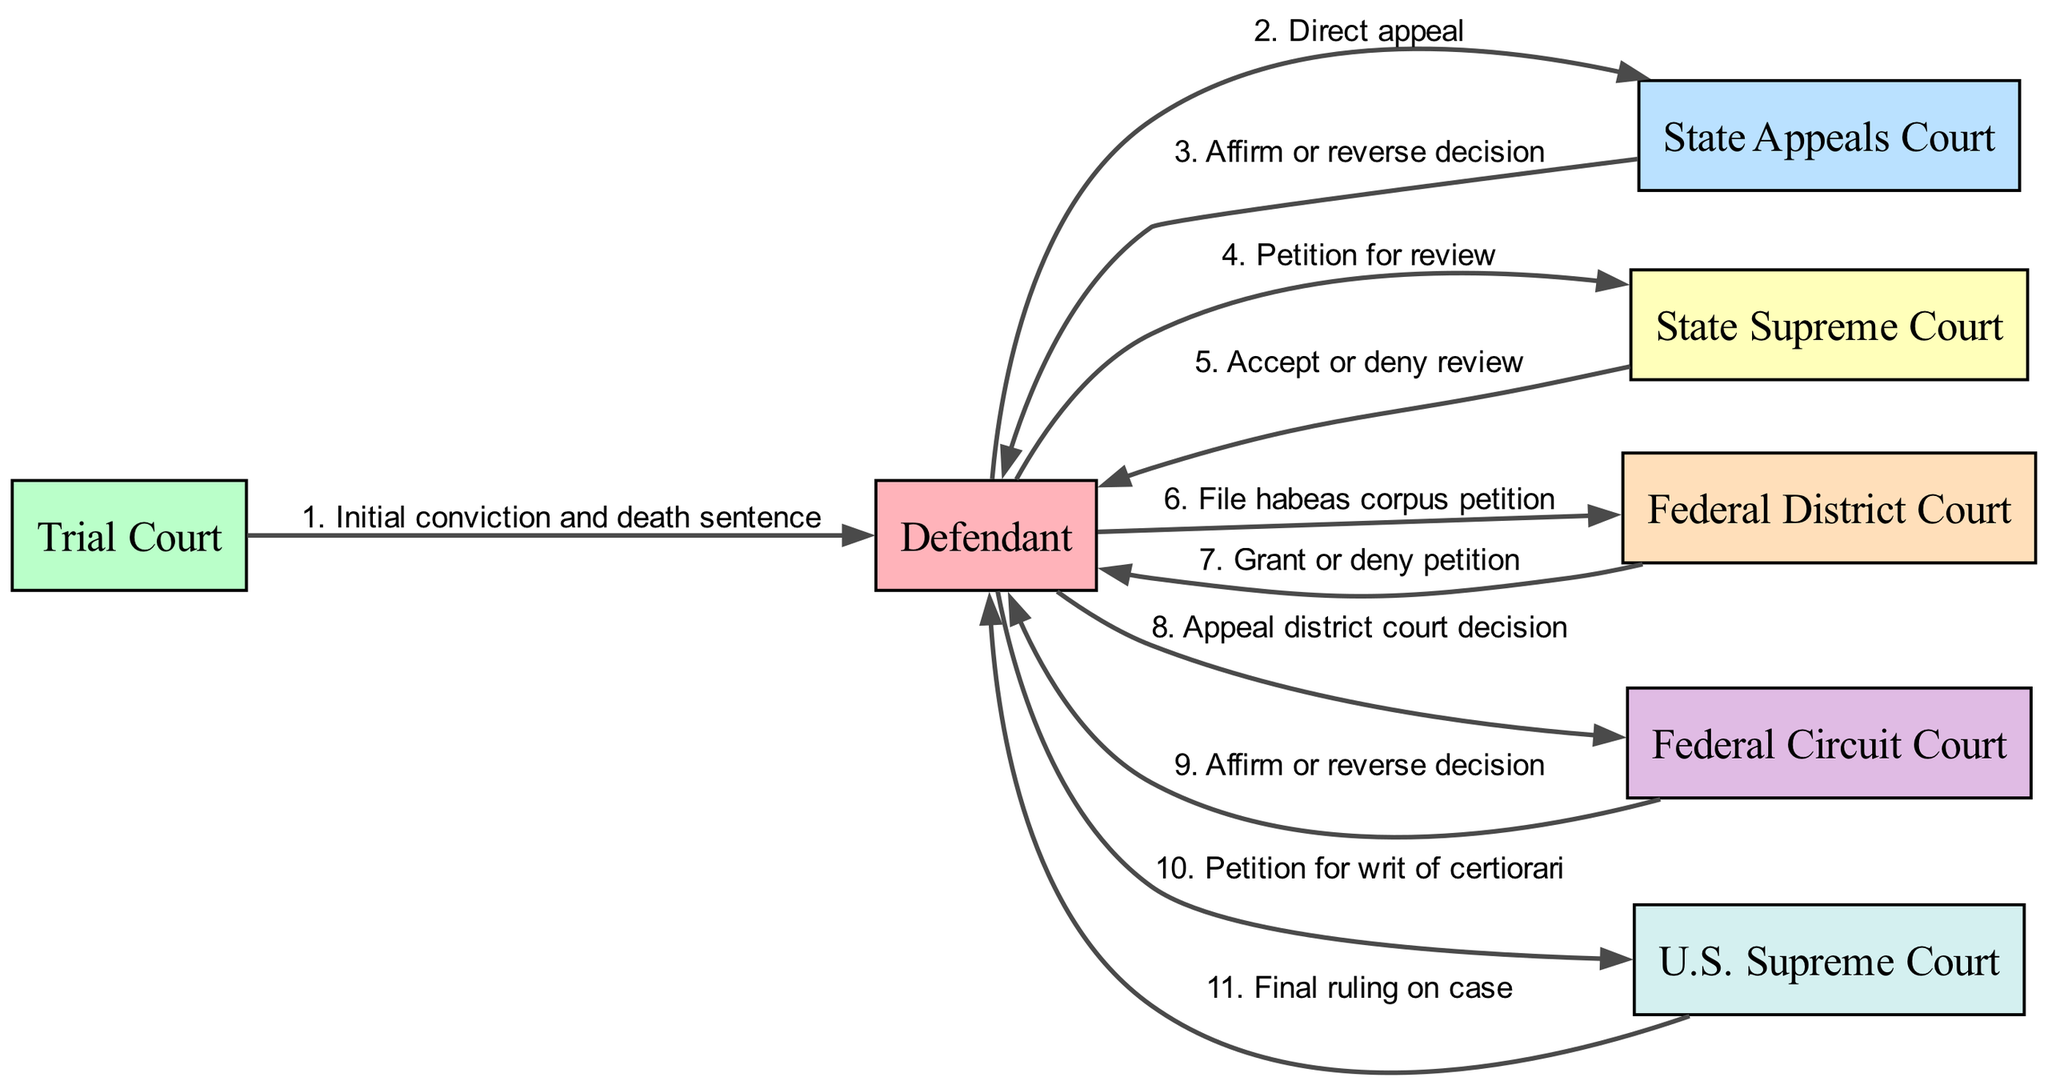What is the first step in the sequence? The first step in the sequence is the action from the Trial Court to the Defendant, which is the initial conviction and death sentence.
Answer: Initial conviction and death sentence How many actors are present in this sequence diagram? The diagram lists six distinct actors involved in the appeals process, which are Defendant, Trial Court, State Appeals Court, State Supreme Court, Federal District Court, Federal Circuit Court, and U.S. Supreme Court.
Answer: Six What is the final ruling made by the U.S. Supreme Court? The final ruling made by the U.S. Supreme Court is provided to the Defendant following a petition for writ of certiorari.
Answer: Final ruling on case Which court does the Defendant appeal to after the Federal District Court? After the Federal District Court, the Defendant appeals to the Federal Circuit Court.
Answer: Federal Circuit Court What does the State Supreme Court do in response to the Defendant's petition? The State Supreme Court decides whether to accept or deny review of the petition submitted by the Defendant.
Answer: Accept or deny review What action does the Defendant take after the decision from the State Appeals Court? After the decision from the State Appeals Court, the Defendant takes the action of filing a petition for review with the State Supreme Court.
Answer: Petition for review How many steps involve the Defendant appealing a decision? There are three steps where the Defendant is involved in appealing a decision throughout the entire sequence of appeals: the direct appeal to the State Appeals Court, the appeal to the Federal Circuit Court after the district court decision, and the petition for writ of certiorari to the U.S. Supreme Court.
Answer: Three What is the role of the State Appeals Court in the sequence? The role of the State Appeals Court is to affirm or reverse the decision made by the Trial Court regarding the Defendant's conviction and death sentence.
Answer: Affirm or reverse decision What type of petition does the Defendant file with the Federal District Court? The Defendant files a habeas corpus petition with the Federal District Court to challenge the legality of their detention.
Answer: File habeas corpus petition 